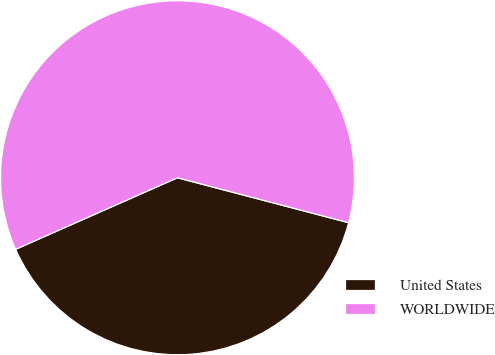Convert chart. <chart><loc_0><loc_0><loc_500><loc_500><pie_chart><fcel>United States<fcel>WORLDWIDE<nl><fcel>39.29%<fcel>60.71%<nl></chart> 